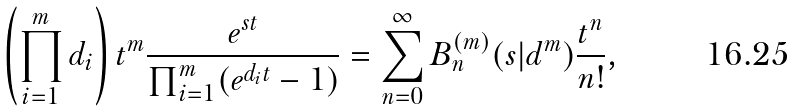<formula> <loc_0><loc_0><loc_500><loc_500>\left ( \prod _ { i = 1 } ^ { m } d _ { i } \right ) t ^ { m } \frac { e ^ { s t } } { \prod _ { i = 1 } ^ { m } ( e ^ { d _ { i } t } - 1 ) } = \sum _ { n = 0 } ^ { \infty } B _ { n } ^ { ( m ) } ( s | { d } ^ { m } ) \frac { t ^ { n } } { n ! } ,</formula> 